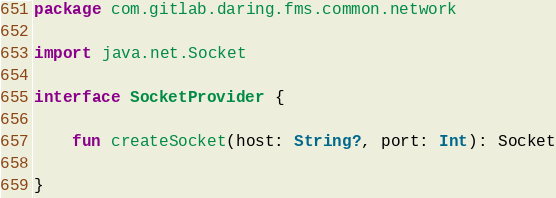<code> <loc_0><loc_0><loc_500><loc_500><_Kotlin_>package com.gitlab.daring.fms.common.network

import java.net.Socket

interface SocketProvider {

    fun createSocket(host: String?, port: Int): Socket
    
}</code> 